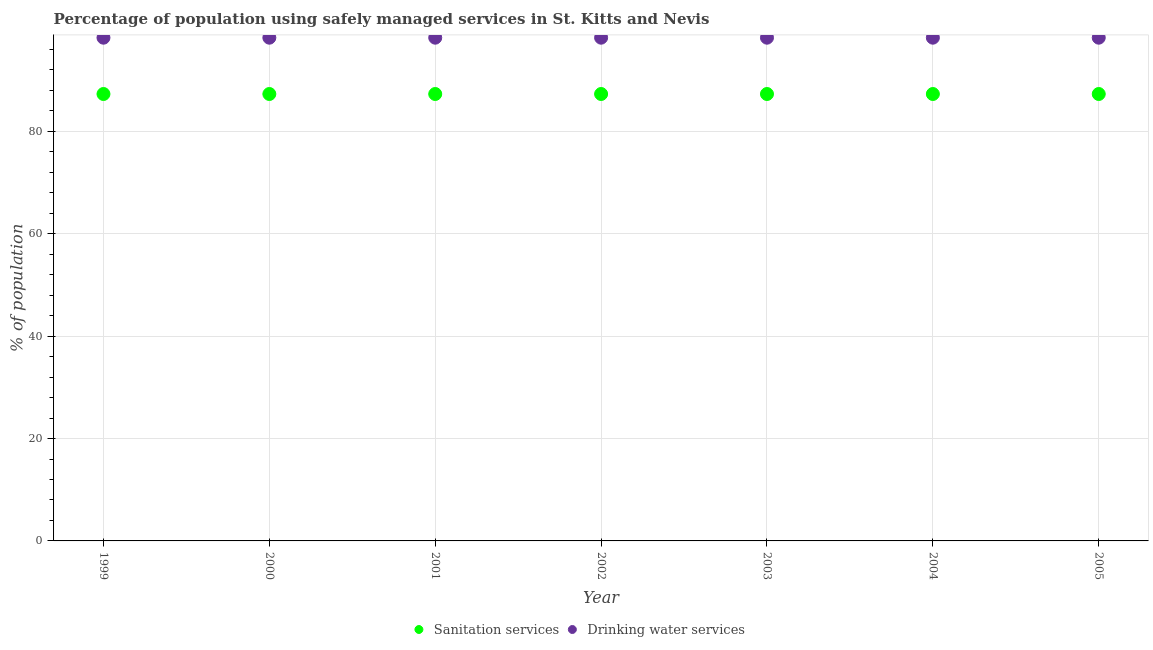Is the number of dotlines equal to the number of legend labels?
Make the answer very short. Yes. What is the percentage of population who used drinking water services in 2003?
Provide a succinct answer. 98.3. Across all years, what is the maximum percentage of population who used drinking water services?
Your response must be concise. 98.3. Across all years, what is the minimum percentage of population who used sanitation services?
Offer a terse response. 87.3. In which year was the percentage of population who used drinking water services minimum?
Your answer should be compact. 1999. What is the total percentage of population who used drinking water services in the graph?
Your answer should be compact. 688.1. What is the average percentage of population who used drinking water services per year?
Keep it short and to the point. 98.3. In the year 2000, what is the difference between the percentage of population who used sanitation services and percentage of population who used drinking water services?
Give a very brief answer. -11. In how many years, is the percentage of population who used sanitation services greater than 24 %?
Offer a terse response. 7. Is the percentage of population who used drinking water services in 1999 less than that in 2001?
Your answer should be very brief. No. Is the difference between the percentage of population who used drinking water services in 1999 and 2004 greater than the difference between the percentage of population who used sanitation services in 1999 and 2004?
Make the answer very short. No. What is the difference between the highest and the second highest percentage of population who used drinking water services?
Give a very brief answer. 0. In how many years, is the percentage of population who used sanitation services greater than the average percentage of population who used sanitation services taken over all years?
Offer a terse response. 7. Is the sum of the percentage of population who used sanitation services in 2001 and 2004 greater than the maximum percentage of population who used drinking water services across all years?
Give a very brief answer. Yes. Does the percentage of population who used sanitation services monotonically increase over the years?
Your answer should be compact. No. Is the percentage of population who used drinking water services strictly less than the percentage of population who used sanitation services over the years?
Offer a very short reply. No. How many dotlines are there?
Ensure brevity in your answer.  2. How many years are there in the graph?
Offer a terse response. 7. Are the values on the major ticks of Y-axis written in scientific E-notation?
Your answer should be compact. No. How many legend labels are there?
Give a very brief answer. 2. How are the legend labels stacked?
Your answer should be very brief. Horizontal. What is the title of the graph?
Keep it short and to the point. Percentage of population using safely managed services in St. Kitts and Nevis. What is the label or title of the X-axis?
Your answer should be compact. Year. What is the label or title of the Y-axis?
Offer a very short reply. % of population. What is the % of population of Sanitation services in 1999?
Your answer should be compact. 87.3. What is the % of population of Drinking water services in 1999?
Make the answer very short. 98.3. What is the % of population of Sanitation services in 2000?
Keep it short and to the point. 87.3. What is the % of population of Drinking water services in 2000?
Provide a succinct answer. 98.3. What is the % of population in Sanitation services in 2001?
Your answer should be compact. 87.3. What is the % of population of Drinking water services in 2001?
Give a very brief answer. 98.3. What is the % of population of Sanitation services in 2002?
Give a very brief answer. 87.3. What is the % of population of Drinking water services in 2002?
Ensure brevity in your answer.  98.3. What is the % of population in Sanitation services in 2003?
Offer a terse response. 87.3. What is the % of population of Drinking water services in 2003?
Offer a terse response. 98.3. What is the % of population in Sanitation services in 2004?
Offer a terse response. 87.3. What is the % of population of Drinking water services in 2004?
Provide a succinct answer. 98.3. What is the % of population of Sanitation services in 2005?
Keep it short and to the point. 87.3. What is the % of population of Drinking water services in 2005?
Offer a terse response. 98.3. Across all years, what is the maximum % of population in Sanitation services?
Provide a short and direct response. 87.3. Across all years, what is the maximum % of population of Drinking water services?
Your answer should be compact. 98.3. Across all years, what is the minimum % of population in Sanitation services?
Ensure brevity in your answer.  87.3. Across all years, what is the minimum % of population of Drinking water services?
Your answer should be compact. 98.3. What is the total % of population in Sanitation services in the graph?
Offer a very short reply. 611.1. What is the total % of population of Drinking water services in the graph?
Provide a short and direct response. 688.1. What is the difference between the % of population of Drinking water services in 1999 and that in 2000?
Provide a succinct answer. 0. What is the difference between the % of population in Sanitation services in 1999 and that in 2001?
Your response must be concise. 0. What is the difference between the % of population in Sanitation services in 1999 and that in 2002?
Give a very brief answer. 0. What is the difference between the % of population of Sanitation services in 1999 and that in 2004?
Make the answer very short. 0. What is the difference between the % of population of Sanitation services in 1999 and that in 2005?
Ensure brevity in your answer.  0. What is the difference between the % of population in Drinking water services in 1999 and that in 2005?
Your answer should be compact. 0. What is the difference between the % of population in Sanitation services in 2000 and that in 2002?
Your answer should be compact. 0. What is the difference between the % of population in Drinking water services in 2000 and that in 2002?
Your answer should be very brief. 0. What is the difference between the % of population in Sanitation services in 2000 and that in 2003?
Offer a terse response. 0. What is the difference between the % of population in Sanitation services in 2000 and that in 2005?
Ensure brevity in your answer.  0. What is the difference between the % of population in Sanitation services in 2001 and that in 2002?
Your answer should be compact. 0. What is the difference between the % of population of Sanitation services in 2001 and that in 2003?
Your answer should be compact. 0. What is the difference between the % of population of Drinking water services in 2001 and that in 2004?
Provide a succinct answer. 0. What is the difference between the % of population in Sanitation services in 2001 and that in 2005?
Your response must be concise. 0. What is the difference between the % of population of Drinking water services in 2001 and that in 2005?
Make the answer very short. 0. What is the difference between the % of population of Drinking water services in 2002 and that in 2003?
Offer a terse response. 0. What is the difference between the % of population in Sanitation services in 2002 and that in 2004?
Provide a short and direct response. 0. What is the difference between the % of population in Drinking water services in 2002 and that in 2004?
Offer a terse response. 0. What is the difference between the % of population of Sanitation services in 2003 and that in 2004?
Provide a succinct answer. 0. What is the difference between the % of population of Drinking water services in 2003 and that in 2004?
Your answer should be very brief. 0. What is the difference between the % of population in Sanitation services in 2003 and that in 2005?
Your response must be concise. 0. What is the difference between the % of population in Drinking water services in 2003 and that in 2005?
Provide a short and direct response. 0. What is the difference between the % of population of Drinking water services in 2004 and that in 2005?
Provide a short and direct response. 0. What is the difference between the % of population in Sanitation services in 1999 and the % of population in Drinking water services in 2000?
Your response must be concise. -11. What is the difference between the % of population in Sanitation services in 1999 and the % of population in Drinking water services in 2001?
Make the answer very short. -11. What is the difference between the % of population in Sanitation services in 2000 and the % of population in Drinking water services in 2002?
Your answer should be compact. -11. What is the difference between the % of population in Sanitation services in 2000 and the % of population in Drinking water services in 2005?
Provide a short and direct response. -11. What is the difference between the % of population in Sanitation services in 2001 and the % of population in Drinking water services in 2002?
Provide a short and direct response. -11. What is the difference between the % of population in Sanitation services in 2001 and the % of population in Drinking water services in 2004?
Your answer should be very brief. -11. What is the difference between the % of population in Sanitation services in 2002 and the % of population in Drinking water services in 2005?
Your response must be concise. -11. What is the difference between the % of population of Sanitation services in 2003 and the % of population of Drinking water services in 2004?
Offer a terse response. -11. What is the difference between the % of population in Sanitation services in 2004 and the % of population in Drinking water services in 2005?
Provide a succinct answer. -11. What is the average % of population in Sanitation services per year?
Provide a succinct answer. 87.3. What is the average % of population of Drinking water services per year?
Your answer should be very brief. 98.3. In the year 1999, what is the difference between the % of population of Sanitation services and % of population of Drinking water services?
Keep it short and to the point. -11. In the year 2002, what is the difference between the % of population of Sanitation services and % of population of Drinking water services?
Provide a succinct answer. -11. In the year 2003, what is the difference between the % of population in Sanitation services and % of population in Drinking water services?
Give a very brief answer. -11. In the year 2004, what is the difference between the % of population in Sanitation services and % of population in Drinking water services?
Offer a very short reply. -11. In the year 2005, what is the difference between the % of population in Sanitation services and % of population in Drinking water services?
Provide a succinct answer. -11. What is the ratio of the % of population of Sanitation services in 1999 to that in 2001?
Your response must be concise. 1. What is the ratio of the % of population in Drinking water services in 1999 to that in 2001?
Keep it short and to the point. 1. What is the ratio of the % of population of Sanitation services in 1999 to that in 2002?
Your answer should be very brief. 1. What is the ratio of the % of population in Sanitation services in 1999 to that in 2003?
Offer a very short reply. 1. What is the ratio of the % of population in Drinking water services in 1999 to that in 2003?
Provide a short and direct response. 1. What is the ratio of the % of population of Drinking water services in 1999 to that in 2004?
Your response must be concise. 1. What is the ratio of the % of population of Sanitation services in 1999 to that in 2005?
Provide a succinct answer. 1. What is the ratio of the % of population in Drinking water services in 1999 to that in 2005?
Your response must be concise. 1. What is the ratio of the % of population of Sanitation services in 2000 to that in 2001?
Your answer should be compact. 1. What is the ratio of the % of population of Sanitation services in 2000 to that in 2002?
Your answer should be very brief. 1. What is the ratio of the % of population of Drinking water services in 2000 to that in 2002?
Your answer should be compact. 1. What is the ratio of the % of population in Sanitation services in 2000 to that in 2003?
Your response must be concise. 1. What is the ratio of the % of population in Drinking water services in 2000 to that in 2003?
Your answer should be compact. 1. What is the ratio of the % of population in Drinking water services in 2000 to that in 2004?
Give a very brief answer. 1. What is the ratio of the % of population in Sanitation services in 2001 to that in 2002?
Offer a very short reply. 1. What is the ratio of the % of population of Drinking water services in 2001 to that in 2002?
Your answer should be compact. 1. What is the ratio of the % of population in Sanitation services in 2001 to that in 2003?
Ensure brevity in your answer.  1. What is the ratio of the % of population of Drinking water services in 2001 to that in 2003?
Make the answer very short. 1. What is the ratio of the % of population of Sanitation services in 2001 to that in 2004?
Make the answer very short. 1. What is the ratio of the % of population in Sanitation services in 2001 to that in 2005?
Offer a terse response. 1. What is the ratio of the % of population in Drinking water services in 2001 to that in 2005?
Give a very brief answer. 1. What is the ratio of the % of population of Sanitation services in 2002 to that in 2003?
Make the answer very short. 1. What is the ratio of the % of population in Sanitation services in 2002 to that in 2004?
Your answer should be very brief. 1. What is the ratio of the % of population of Drinking water services in 2002 to that in 2004?
Offer a terse response. 1. What is the ratio of the % of population in Sanitation services in 2002 to that in 2005?
Offer a terse response. 1. What is the ratio of the % of population of Drinking water services in 2002 to that in 2005?
Make the answer very short. 1. What is the ratio of the % of population in Sanitation services in 2003 to that in 2004?
Provide a succinct answer. 1. What is the ratio of the % of population of Drinking water services in 2003 to that in 2004?
Keep it short and to the point. 1. What is the ratio of the % of population of Sanitation services in 2003 to that in 2005?
Give a very brief answer. 1. What is the ratio of the % of population of Drinking water services in 2003 to that in 2005?
Give a very brief answer. 1. What is the ratio of the % of population in Drinking water services in 2004 to that in 2005?
Make the answer very short. 1. What is the difference between the highest and the second highest % of population of Sanitation services?
Your answer should be very brief. 0. What is the difference between the highest and the lowest % of population of Sanitation services?
Offer a terse response. 0. 